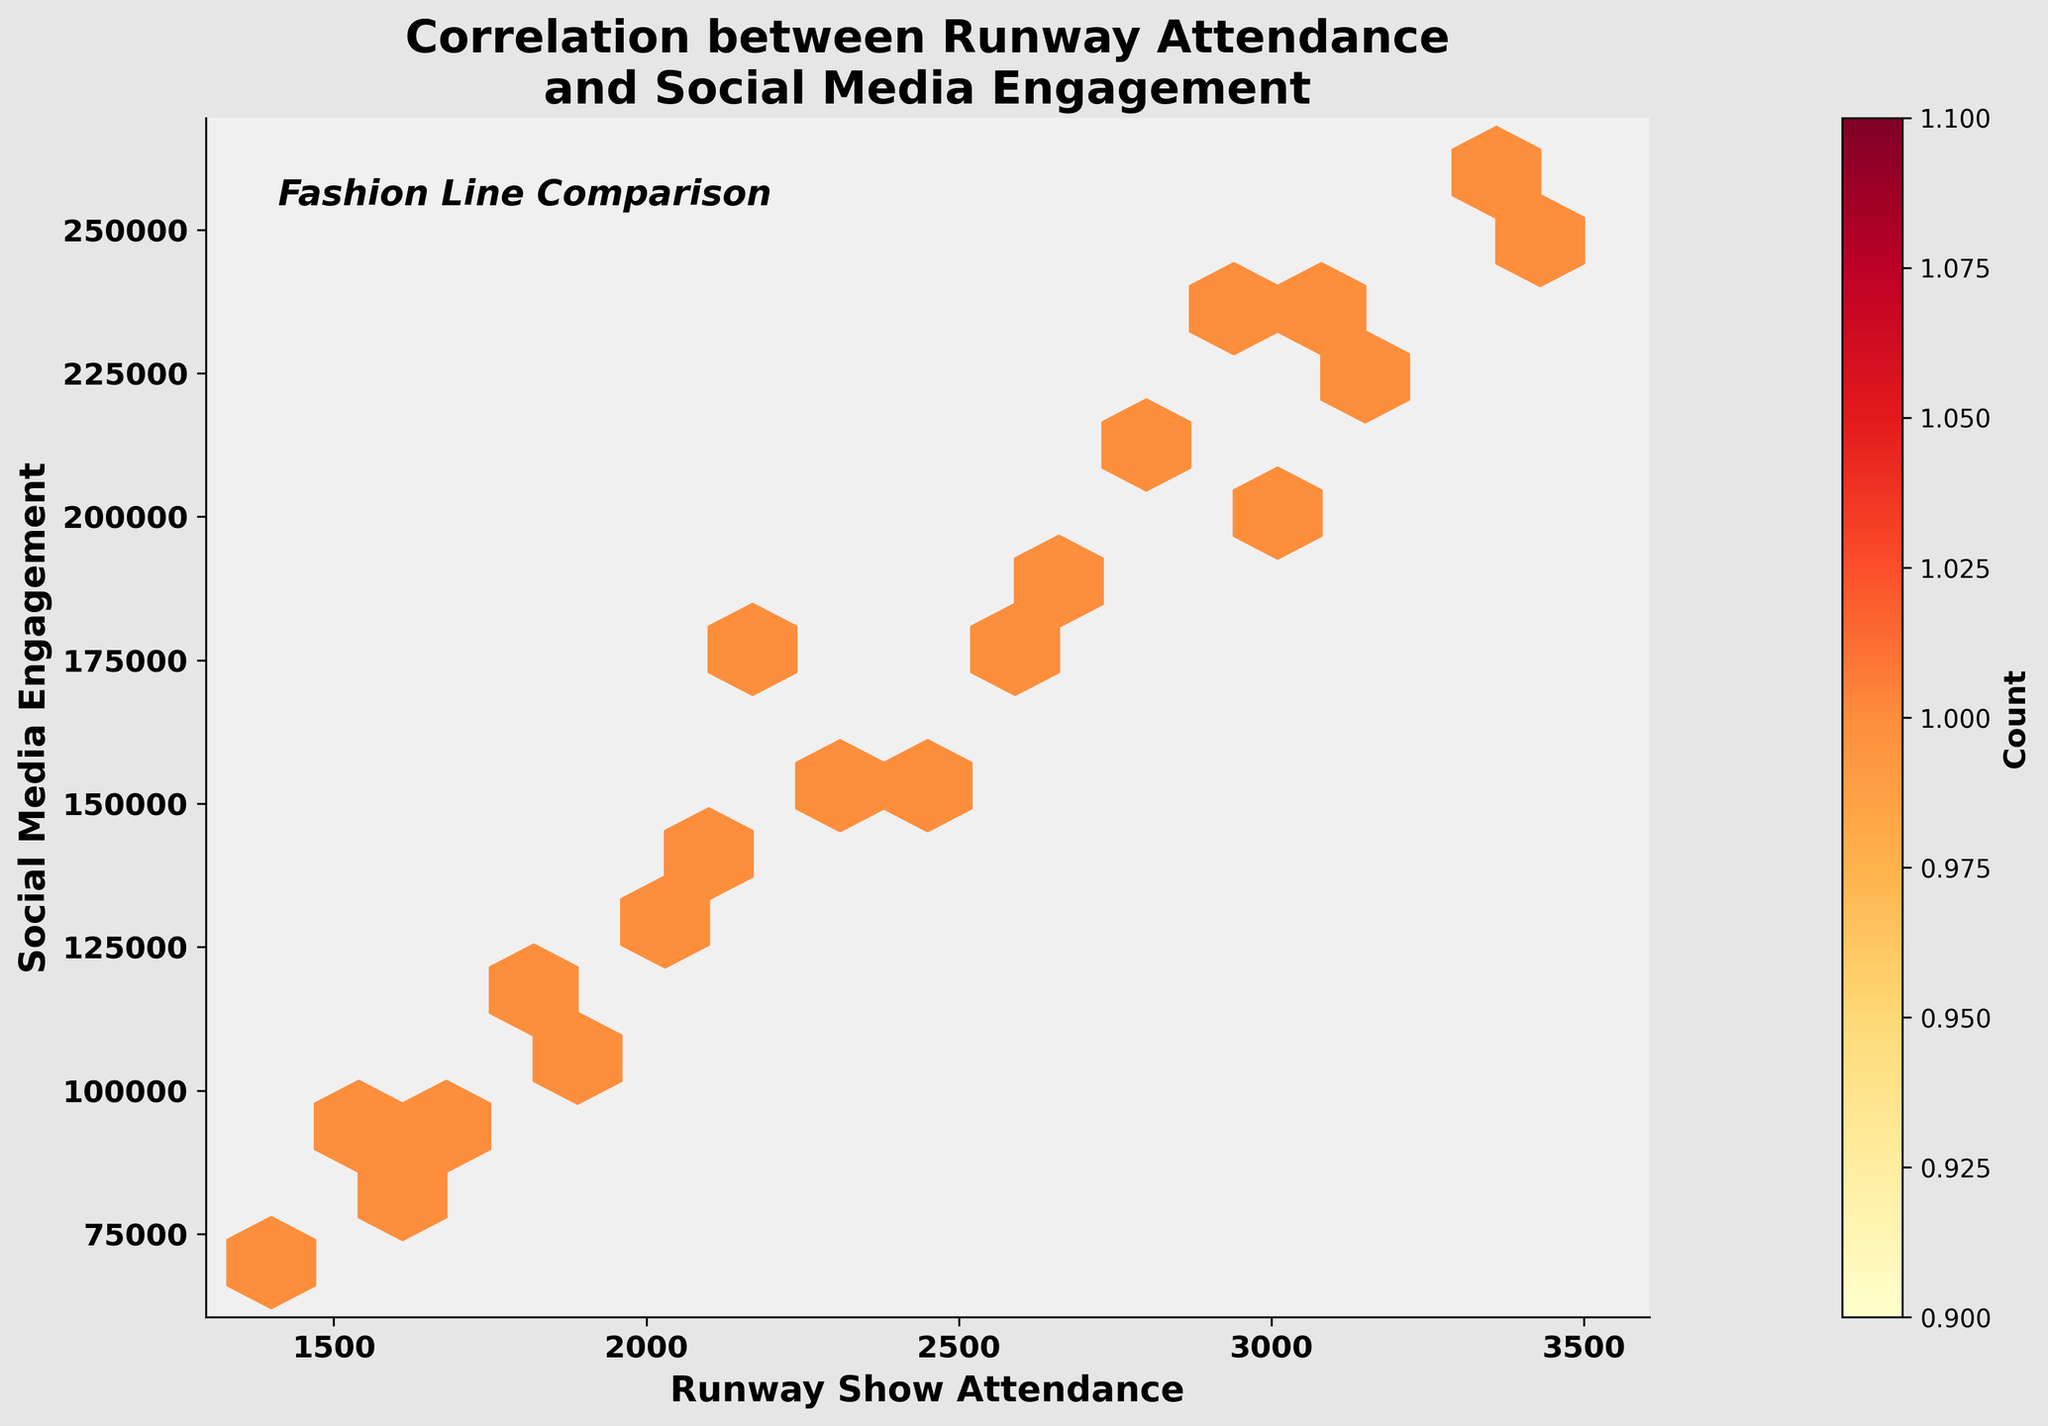How many data points are shown in the plot? The Hexbin plot aggregates data points into hexagonal bins. By counting the colored bins, you can determine the number of aggregated points. However, since each bin might contain more than one data point, this is just an approximation.
Answer: 20 What are the units on the x-axis and y-axis? The x-axis represents "Runway Show Attendance," and the y-axis represents "Social Media Engagement." Both axes use numerical counts running continuously.
Answer: Runway Show Attendance and Social Media Engagement What is the general trend observed in the Hexbin plot between runway attendance and social media engagement? By observing the hexagonal bins' density and distribution, you can see that as runway show attendance increases, social media engagement tends to increase accordingly. This is evidenced by the concentration of bins moving diagonally upwards from left to right.
Answer: Positive correlation Which fashion line has the highest social media engagement, and what is its corresponding runway attendance? By identifying the bin in the upper-right part of the plot and referencing the provided data, we can determine that "Off-White" has the highest engagement at 260,000 with an attendance of 3,300.
Answer: Off-White, 3,300 What can you infer from the bin counts as indicated by the color scale? The color scale presents the number of data points within each bin. Higher density (shown in darker colors) suggests more fashion lines are grouped in that range of attendance and engagement. Observing the scale, most data points cluster around the medium-high attendance and engagement levels.
Answer: Higher concentration in medium-high range Is there any fashion line that breaks the observed trend between runway show attendance and social media engagement? Most fashion lines follow a linear trend where increased attendance correlates with higher engagement. But examining outliers in the hexbin plot, we don't see any clear deviations from this trend.
Answer: None significantly How does the Social Media Engagement vary for fashion lines with less than 2000 runway show attendance? Observing the lower part of the x-axis (<2000), check the corresponding hex bins' colors and y-axis values to see the engagement levels. Engagement levels in this range generally vary between 70,000 and 140,000.
Answer: 70,000-140,000 Which bin contains the highest number of data points, and what range of attendance and engagement does it represent? The darkest hexagonal bin indicates the highest data point density. By checking the color scale and plot, this bin is around 2,600 to 3,000 attendance and 190,000 to 250,000 engagement.
Answer: 2,600-3,000 attendance, 190,000-250,000 engagement What is the average social media engagement for fashion lines with attendance between 2,000 and 3,000? Average the engagement values for fashion lines within the specific attendance range: Givenchy (100,000), Versace (210,000), Valentino (170,000), Dolcce & Gabanna (240,000), Balmain (140,000), Chanel (200,000). (100,000 + 210,000 + 170,000 + 240,000 + 140,000 + 200,000) / 6 = 176,666.67.
Answer: 176,667 